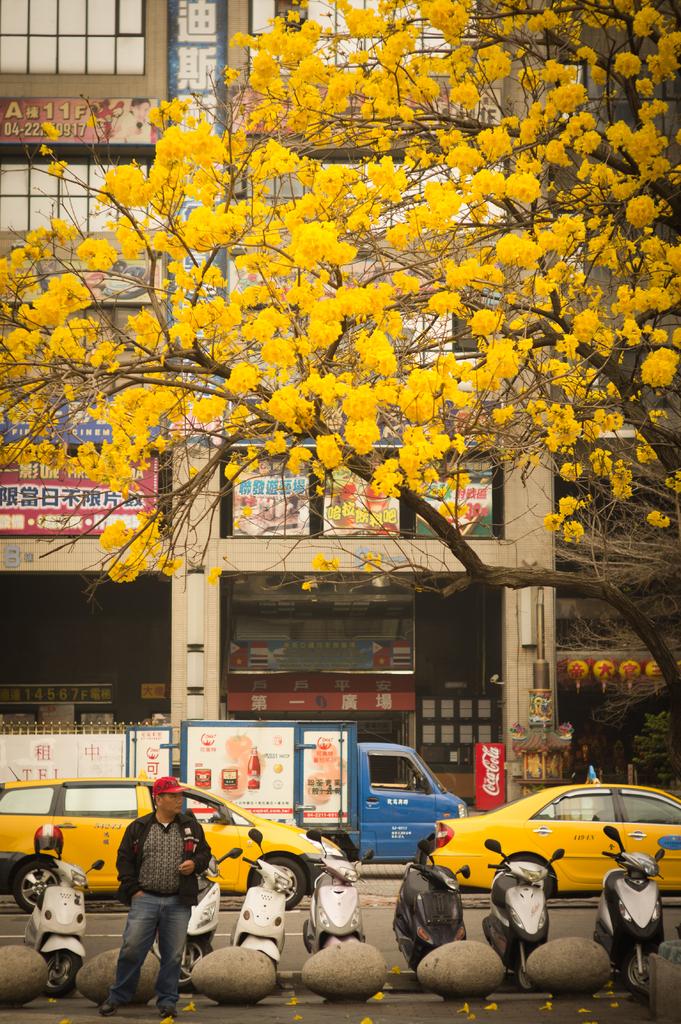What brand of soda is in the machine across the street?
Keep it short and to the point. Coca cola. 